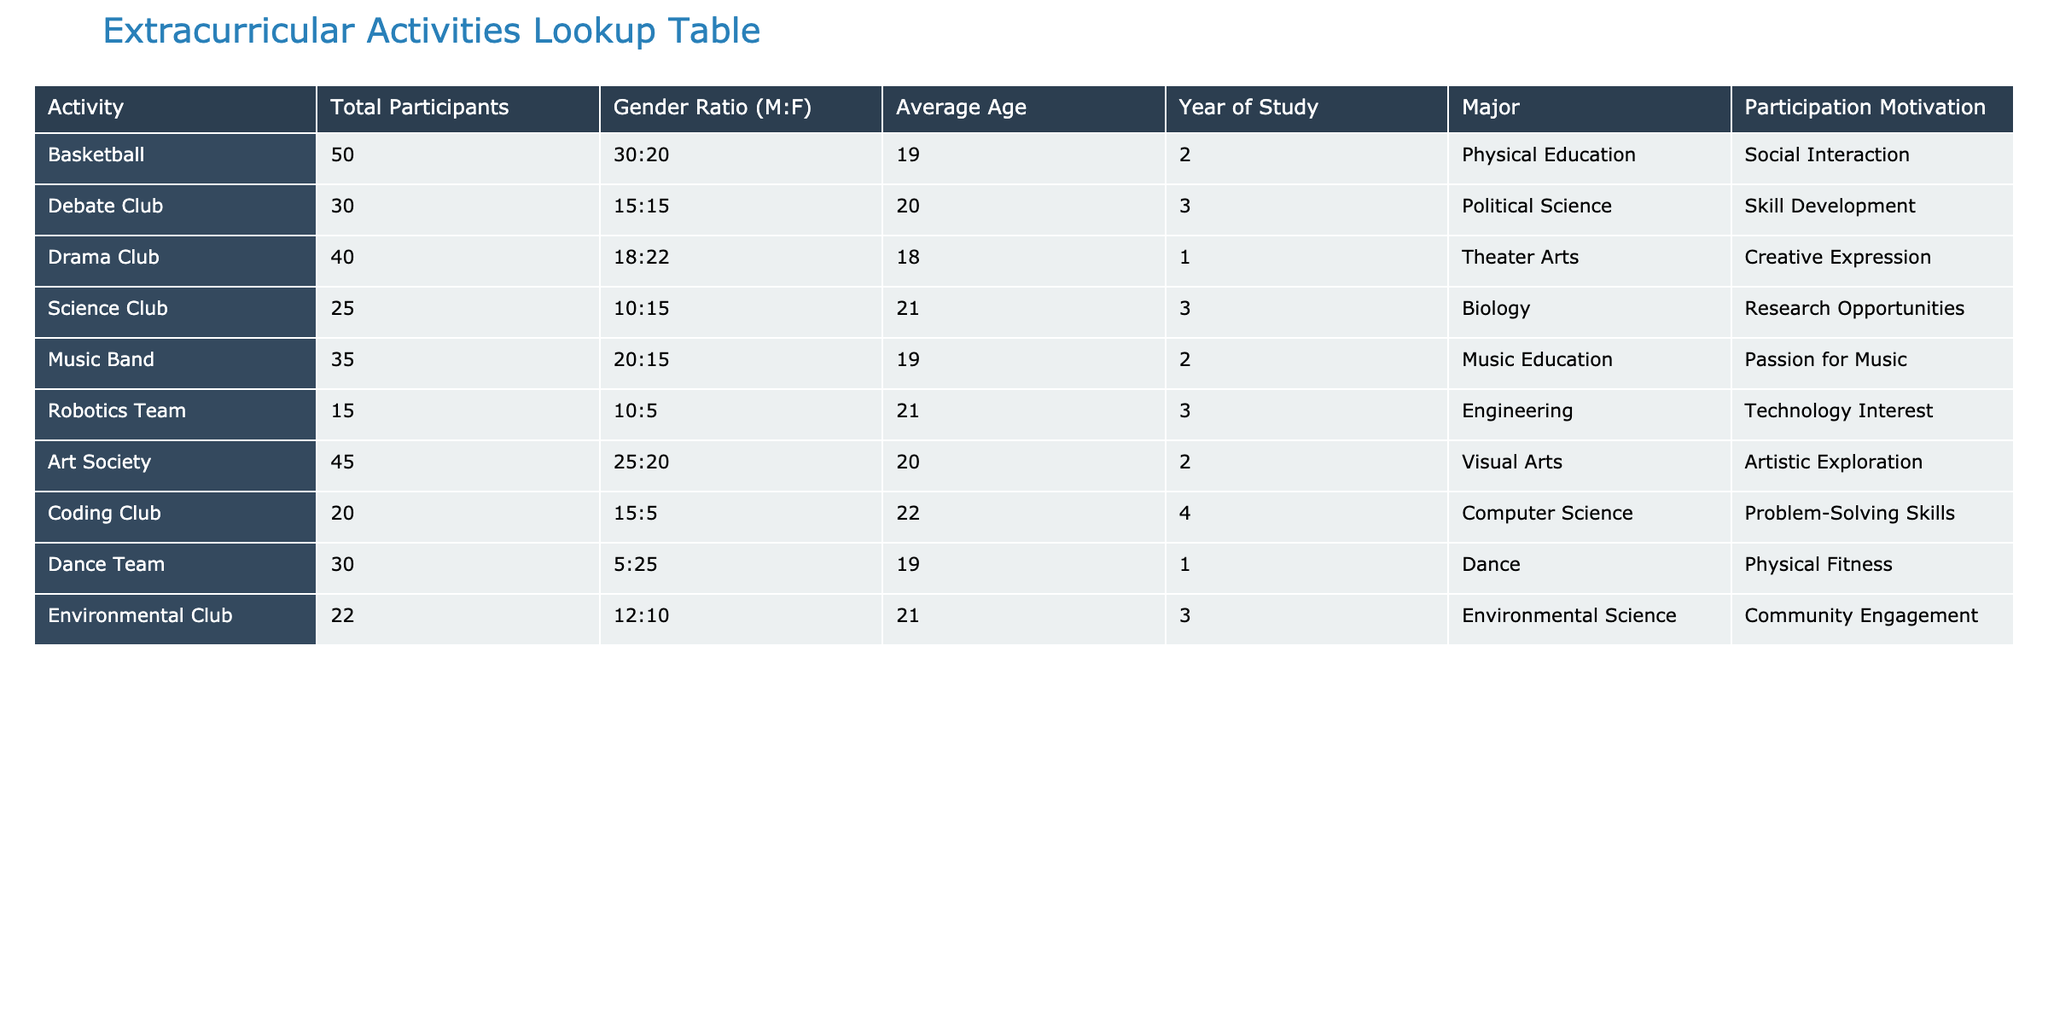What is the total number of participants in the Dance Team? The table shows that the Dance Team has 30 total participants listed in the "Total Participants" column.
Answer: 30 What is the gender ratio of students in the Debate Club? The gender ratio for the Debate Club is found in the "Gender Ratio (M:F)" column and is listed as 15:15, meaning there are equal numbers of male and female participants.
Answer: 15:15 Which activity has the highest average age of participants? By looking at the "Average Age" column, the Robotics Team and Coding Club each have an average age of 21, but the Robotics Team has fewer participants, making it a less popular choice. The Science Club also has an average age of 21 but has more participants than the Robotics Team.
Answer: Robotics Team and Coding Club have the highest average age (21) How many total male participants are there in the Art Society? To find the total number of male participants in the Art Society, we note the gender ratio of 25:20, indicating 25 males in a total of 45 participants.
Answer: 25 Is the majority of participants in the Music Band male? The gender ratio of the Music Band is 20:15, which shows that there are more males (20) than females (15). Thus, the majority are male.
Answer: Yes Which year of study has the highest participation in the Science Club? The Science Club has only participants from the third year of study, as indicated in the "Year of Study" column. There are 25 participants, all from this year.
Answer: Third year What is the total number of participants across all activities? By adding the total participants from all the listed activities: 50 + 30 + 40 + 25 + 35 + 15 + 45 + 20 + 30 + 22, which equals 392 participants in total.
Answer: 392 Which activity is motivated primarily by "Creative Expression"? The Drama Club lists "Creative Expression" under "Participation Motivation," clearly indicating this motivation aligns with its purpose.
Answer: Drama Club How many more participants are involved in the Environmental Club compared to the Robotics Team? The Environmental Club has 22 participants and the Robotics Team has 15. Subtracting these values gives 22 - 15 = 7 more participants in the Environmental Club.
Answer: 7 